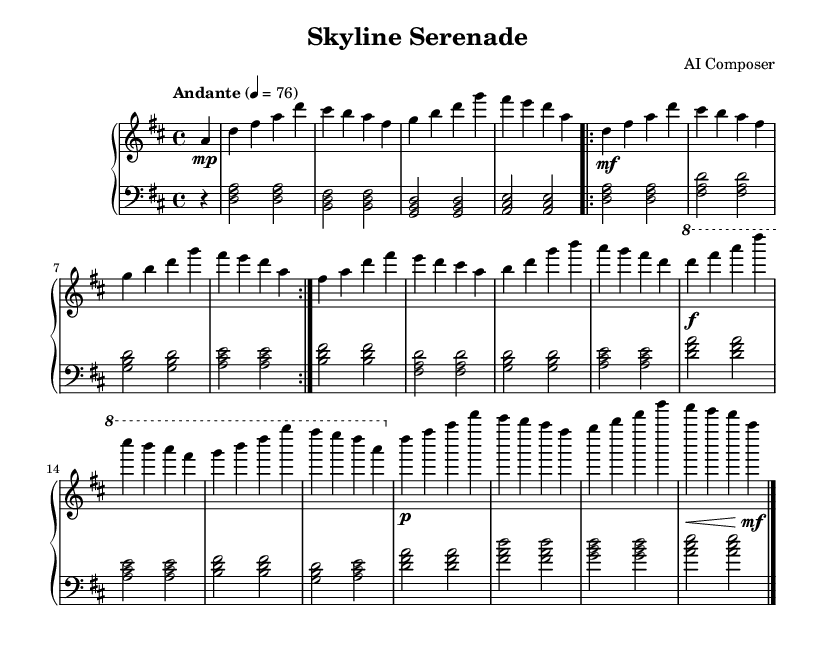What is the key signature of this music? The key signature is indicated at the beginning of the staff. It shows two sharps, which means the composition is in D major.
Answer: D major What is the time signature of this piece? The time signature is displayed at the beginning of the score, appearing as a fraction. It is 4 over 4, which means there are four beats in each measure and a quarter note gets one beat.
Answer: 4/4 What is the tempo marking of this composition? The tempo marking is found next to the global section at the beginning. It specifies the speed of the piece as "Andante," indicating a moderately slow pace.
Answer: Andante How many distinct sections are presented in the piece? The structure can be identified by the section labels throughout the music. It contains an Introduction, A Section, B Section, C Section, and Coda, totaling five distinct sections.
Answer: 5 What dynamics are used in the C Section? The dynamics in the C Section can be identified through the markings above the notes. It indicates a forte (f) marking at the start of the section and a decrescendo to a piano (p) in the Coda, indicating loud to soft playing.
Answer: forte Which chord combinations are used in the A Section? The A Section consists of repeated chord progressions that primarily include major and minor triads. The chords represented are D major, B minor, G major, and A major throughout the section, creating a satisfying harmonic progression.
Answer: D major, B minor, G major, A major 